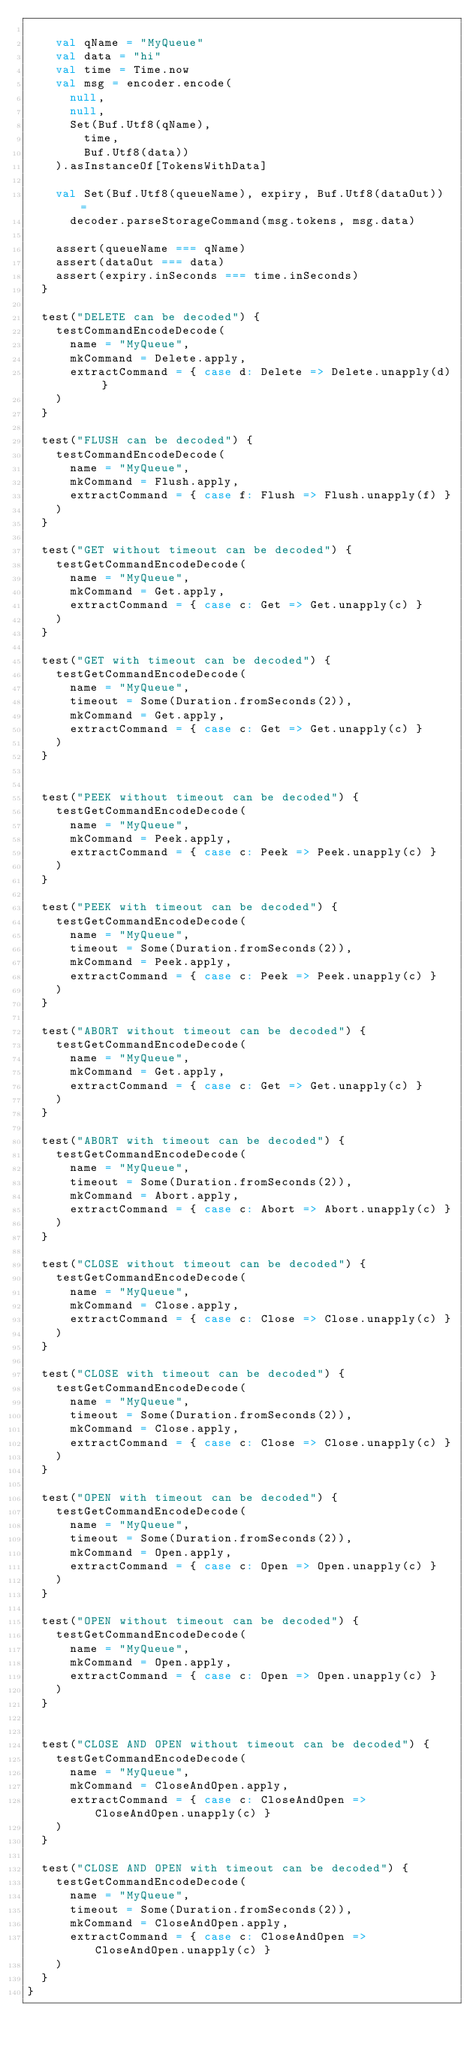<code> <loc_0><loc_0><loc_500><loc_500><_Scala_>
    val qName = "MyQueue"
    val data = "hi"
    val time = Time.now
    val msg = encoder.encode(
      null,
      null,
      Set(Buf.Utf8(qName),
        time,
        Buf.Utf8(data))
    ).asInstanceOf[TokensWithData]

    val Set(Buf.Utf8(queueName), expiry, Buf.Utf8(dataOut)) =
      decoder.parseStorageCommand(msg.tokens, msg.data)

    assert(queueName === qName)
    assert(dataOut === data)
    assert(expiry.inSeconds === time.inSeconds)
  }

  test("DELETE can be decoded") {
    testCommandEncodeDecode(
      name = "MyQueue",
      mkCommand = Delete.apply,
      extractCommand = { case d: Delete => Delete.unapply(d) }
    )
  }

  test("FLUSH can be decoded") {
    testCommandEncodeDecode(
      name = "MyQueue",
      mkCommand = Flush.apply,
      extractCommand = { case f: Flush => Flush.unapply(f) }
    )
  }

  test("GET without timeout can be decoded") {
    testGetCommandEncodeDecode(
      name = "MyQueue",
      mkCommand = Get.apply,
      extractCommand = { case c: Get => Get.unapply(c) }
    )
  }

  test("GET with timeout can be decoded") {
    testGetCommandEncodeDecode(
      name = "MyQueue",
      timeout = Some(Duration.fromSeconds(2)),
      mkCommand = Get.apply,
      extractCommand = { case c: Get => Get.unapply(c) }
    )
  }


  test("PEEK without timeout can be decoded") {
    testGetCommandEncodeDecode(
      name = "MyQueue",
      mkCommand = Peek.apply,
      extractCommand = { case c: Peek => Peek.unapply(c) }
    )
  }

  test("PEEK with timeout can be decoded") {
    testGetCommandEncodeDecode(
      name = "MyQueue",
      timeout = Some(Duration.fromSeconds(2)),
      mkCommand = Peek.apply,
      extractCommand = { case c: Peek => Peek.unapply(c) }
    )
  }

  test("ABORT without timeout can be decoded") {
    testGetCommandEncodeDecode(
      name = "MyQueue",
      mkCommand = Get.apply,
      extractCommand = { case c: Get => Get.unapply(c) }
    )
  }

  test("ABORT with timeout can be decoded") {
    testGetCommandEncodeDecode(
      name = "MyQueue",
      timeout = Some(Duration.fromSeconds(2)),
      mkCommand = Abort.apply,
      extractCommand = { case c: Abort => Abort.unapply(c) }
    )
  }

  test("CLOSE without timeout can be decoded") {
    testGetCommandEncodeDecode(
      name = "MyQueue",
      mkCommand = Close.apply,
      extractCommand = { case c: Close => Close.unapply(c) }
    )
  }

  test("CLOSE with timeout can be decoded") {
    testGetCommandEncodeDecode(
      name = "MyQueue",
      timeout = Some(Duration.fromSeconds(2)),
      mkCommand = Close.apply,
      extractCommand = { case c: Close => Close.unapply(c) }
    )
  }

  test("OPEN with timeout can be decoded") {
    testGetCommandEncodeDecode(
      name = "MyQueue",
      timeout = Some(Duration.fromSeconds(2)),
      mkCommand = Open.apply,
      extractCommand = { case c: Open => Open.unapply(c) }
    )
  }

  test("OPEN without timeout can be decoded") {
    testGetCommandEncodeDecode(
      name = "MyQueue",
      mkCommand = Open.apply,
      extractCommand = { case c: Open => Open.unapply(c) }
    )
  }


  test("CLOSE AND OPEN without timeout can be decoded") {
    testGetCommandEncodeDecode(
      name = "MyQueue",
      mkCommand = CloseAndOpen.apply,
      extractCommand = { case c: CloseAndOpen => CloseAndOpen.unapply(c) }
    )
  }

  test("CLOSE AND OPEN with timeout can be decoded") {
    testGetCommandEncodeDecode(
      name = "MyQueue",
      timeout = Some(Duration.fromSeconds(2)),
      mkCommand = CloseAndOpen.apply,
      extractCommand = { case c: CloseAndOpen => CloseAndOpen.unapply(c) }
    )
  }
}
</code> 